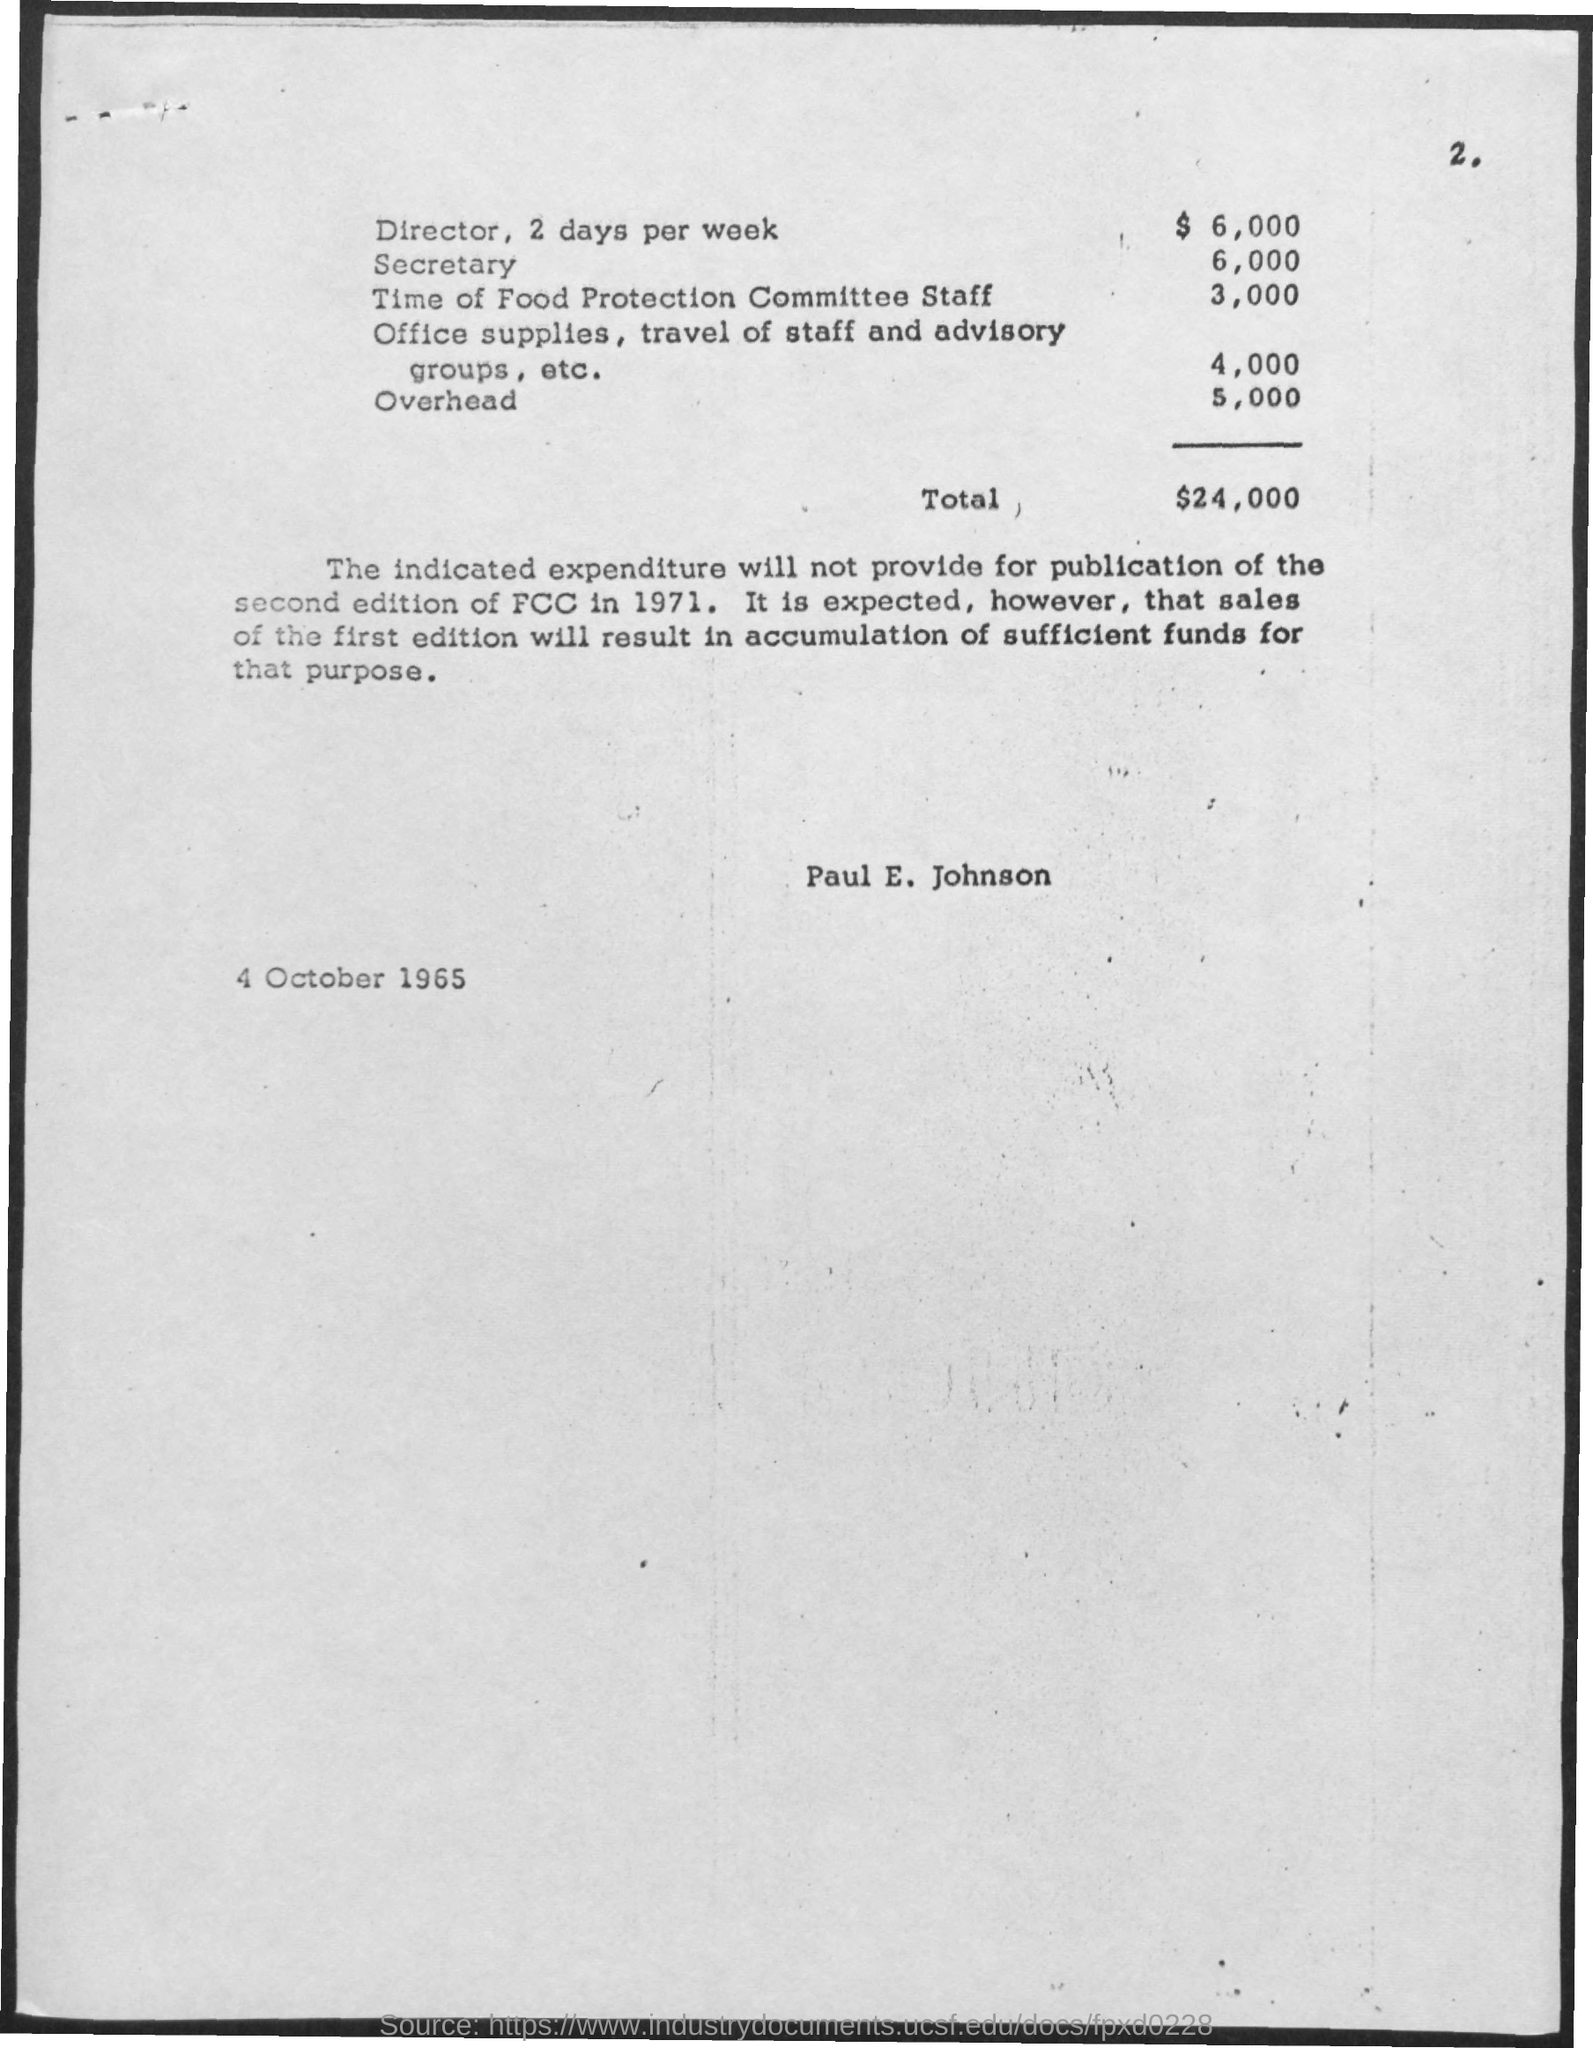What is the total amount of expenditure?
Your answer should be compact. $24,000. What is the page number of the document ?
Provide a short and direct response. 2. What is the amount of overhead expenditure ?
Your answer should be very brief. $5,000. What is amount of director expenditure?
Your answer should be very brief. 6,000. What is the expenditure for secretary ?
Make the answer very short. 6,000. What is the expenditure for time of food protection committee staff?
Your response must be concise. $3,000. What is the expenditure over office supplies, travel of staff and advisory groups, etc.?
Make the answer very short. $4,000. What is the date and year mentioned in the page?
Keep it short and to the point. 4 October 1965. 